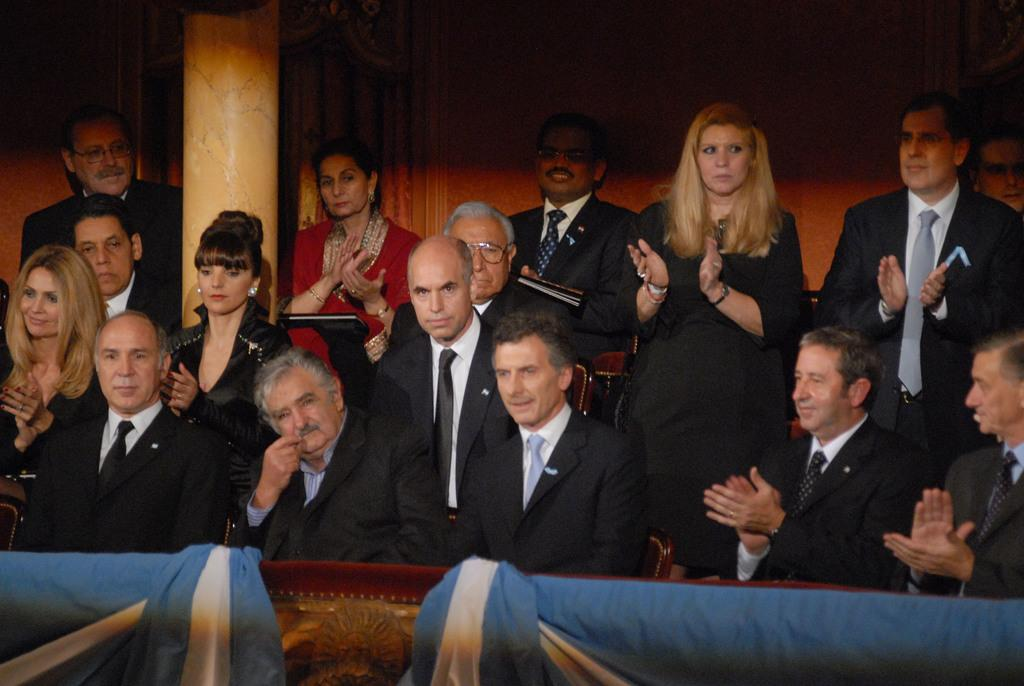Who or what can be seen in the image? There are people in the image. What are some of the people doing in the image? Some of the people are clapping their hands. What can be seen in the background of the image? There is a wall in the background of the image. What type of sheet is being used to cover the plot in the image? There is no sheet or plot present in the image; it features people and a wall in the background. 